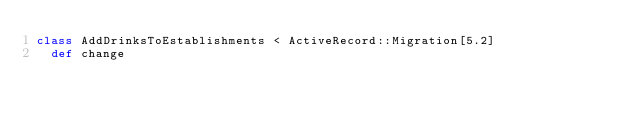<code> <loc_0><loc_0><loc_500><loc_500><_Ruby_>class AddDrinksToEstablishments < ActiveRecord::Migration[5.2]
  def change</code> 